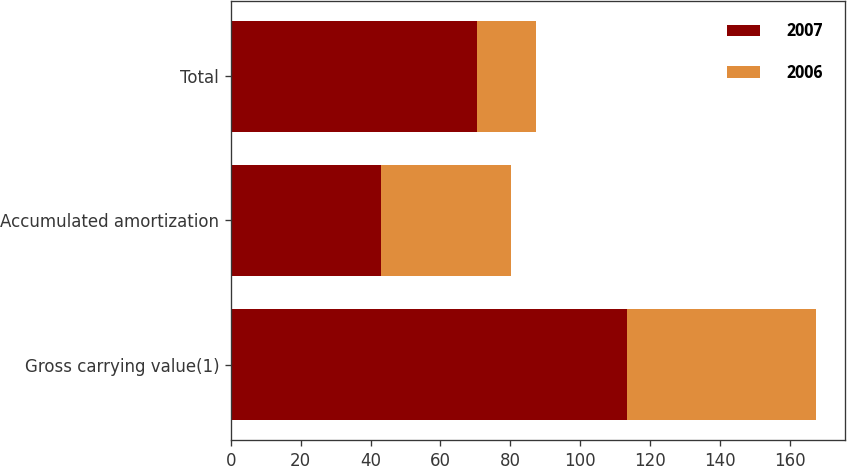Convert chart. <chart><loc_0><loc_0><loc_500><loc_500><stacked_bar_chart><ecel><fcel>Gross carrying value(1)<fcel>Accumulated amortization<fcel>Total<nl><fcel>2007<fcel>113.5<fcel>43.1<fcel>70.4<nl><fcel>2006<fcel>53.9<fcel>37<fcel>16.9<nl></chart> 